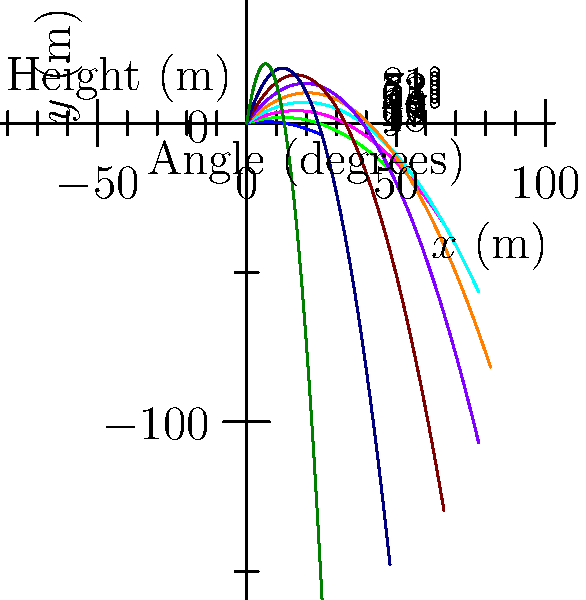As a handball player, you're practicing throwing techniques. The diagram shows trajectories for a handball thrown at different angles with an initial velocity of 20 m/s. Which angle provides the maximum range, and why is this angle considered optimal for long-distance throws in handball? To determine the optimal angle for maximum range in handball throws, we need to consider the following steps:

1. Understand the trajectory equation:
   The path of a projectile (like a handball) is described by the equation:
   $y = x \tan(\theta) - \frac{gx^2}{2v_0^2\cos^2(\theta)}$
   Where $y$ is the vertical position, $x$ is the horizontal position, $\theta$ is the launch angle, $g$ is the acceleration due to gravity, and $v_0$ is the initial velocity.

2. Analyze the range equation:
   The range (R) of a projectile is given by:
   $R = \frac{v_0^2\sin(2\theta)}{g}$

3. Find the maximum range:
   To maximize the range, we need to maximize $\sin(2\theta)$. This occurs when $2\theta = 90°$ or $\theta = 45°$.

4. Observe the diagram:
   The trajectory that reaches the farthest horizontal distance corresponds to the 45° angle.

5. Consider real-world factors:
   In actual handball gameplay, factors like air resistance and the need to throw over defenders might slightly modify the optimal angle. However, 45° remains a good approximation for maximum range.

6. Application to handball:
   For long-distance throws in handball, such as when a goalkeeper attempts to score, aiming for a launch angle close to 45° will generally provide the maximum range.
Answer: 45° 